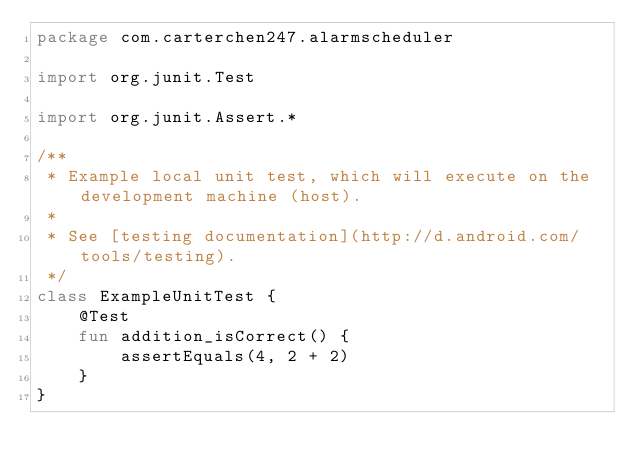Convert code to text. <code><loc_0><loc_0><loc_500><loc_500><_Kotlin_>package com.carterchen247.alarmscheduler

import org.junit.Test

import org.junit.Assert.*

/**
 * Example local unit test, which will execute on the development machine (host).
 *
 * See [testing documentation](http://d.android.com/tools/testing).
 */
class ExampleUnitTest {
    @Test
    fun addition_isCorrect() {
        assertEquals(4, 2 + 2)
    }
}
</code> 